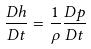<formula> <loc_0><loc_0><loc_500><loc_500>\frac { D h } { D t } = \frac { 1 } { \rho } \frac { D p } { D t }</formula> 